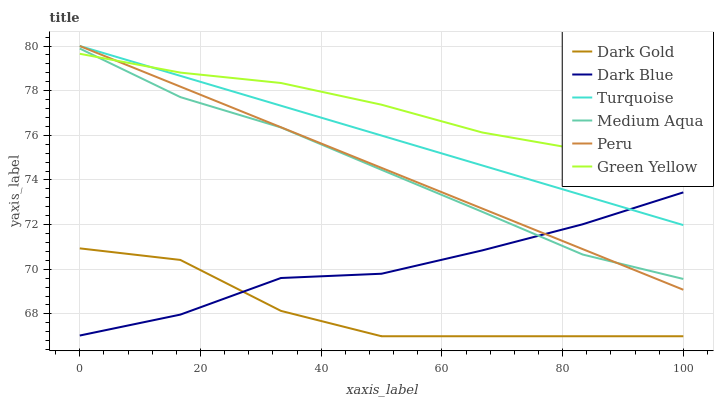Does Dark Gold have the minimum area under the curve?
Answer yes or no. Yes. Does Green Yellow have the maximum area under the curve?
Answer yes or no. Yes. Does Dark Blue have the minimum area under the curve?
Answer yes or no. No. Does Dark Blue have the maximum area under the curve?
Answer yes or no. No. Is Turquoise the smoothest?
Answer yes or no. Yes. Is Dark Gold the roughest?
Answer yes or no. Yes. Is Dark Blue the smoothest?
Answer yes or no. No. Is Dark Blue the roughest?
Answer yes or no. No. Does Dark Gold have the lowest value?
Answer yes or no. Yes. Does Dark Blue have the lowest value?
Answer yes or no. No. Does Peru have the highest value?
Answer yes or no. Yes. Does Dark Blue have the highest value?
Answer yes or no. No. Is Medium Aqua less than Turquoise?
Answer yes or no. Yes. Is Peru greater than Dark Gold?
Answer yes or no. Yes. Does Green Yellow intersect Turquoise?
Answer yes or no. Yes. Is Green Yellow less than Turquoise?
Answer yes or no. No. Is Green Yellow greater than Turquoise?
Answer yes or no. No. Does Medium Aqua intersect Turquoise?
Answer yes or no. No. 